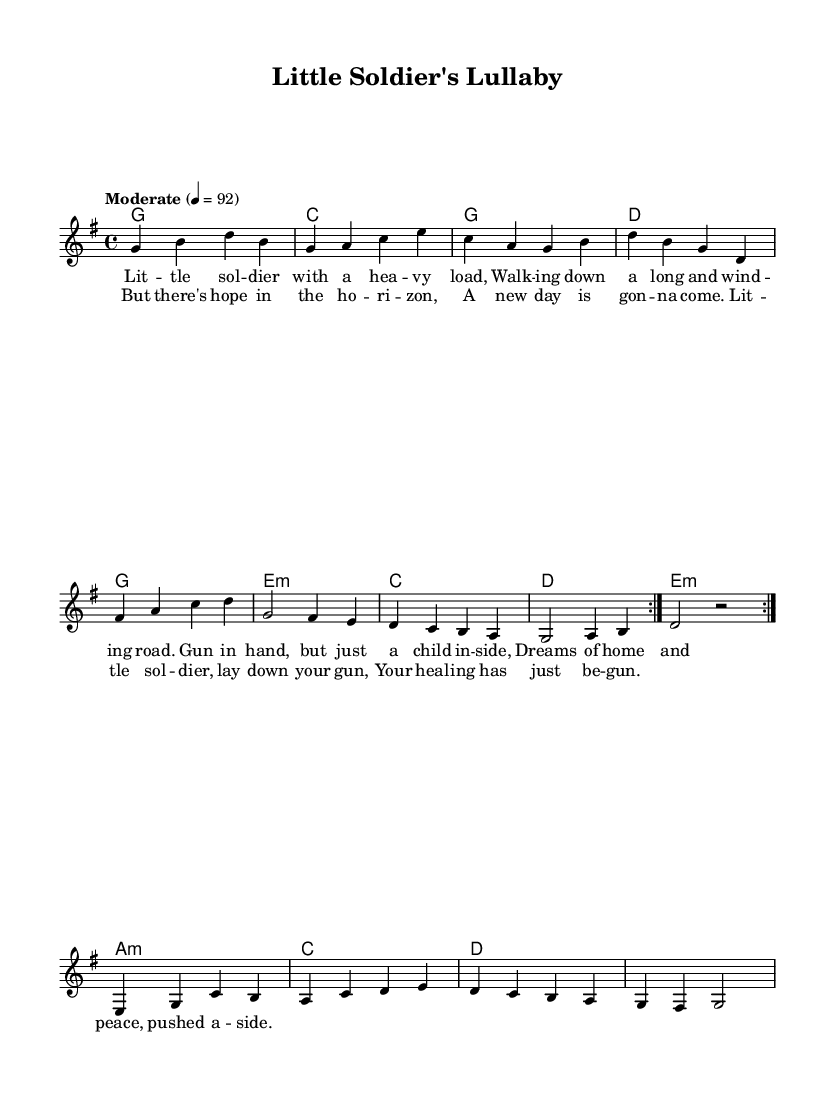What is the key signature of this music? The key signature is G major, which has one sharp, F#. This can be determined by looking at the key signature marking at the beginning of the sheet music.
Answer: G major What is the time signature of this music? The time signature is 4/4, which means there are four beats per measure and the quarter note receives one beat. This is indicated at the beginning of the sheet music.
Answer: 4/4 What is the tempo marking for the piece? The tempo marking is "Moderate" with a metronome marking of 92 beats per minute. This is noted at the beginning of the score, specifying the intended speed for performance.
Answer: Moderate, 92 How many measures are in the first verse? The first verse consists of 4 measures, as shown in the melody under the lyrics section where the verses are broken into distinct lines, and each line corresponds to four measures.
Answer: 4 Which chord appears most frequently in the harmonies? The G chord appears most frequently in the harmonies, as we can see it listed multiple times throughout the chord progression in the music sheet.
Answer: G In the chorus, what is the first lyric line? The first lyric line of the chorus is "But there's hope in the ho-ri-zon". This can be found by reading the text aligned with the music notes for the chorus section of the sheet.
Answer: But there's hope in the ho-ri-zon What is a characteristic feature of country rock reflected in this song's structure? A characteristic feature is the storytelling element, evident in the verses that narrate the journey and struggles of the child soldier, which aligns with the genre's focus on narrative and emotion.
Answer: Storytelling element 